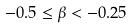<formula> <loc_0><loc_0><loc_500><loc_500>- 0 . 5 \leq \beta < - 0 . 2 5</formula> 